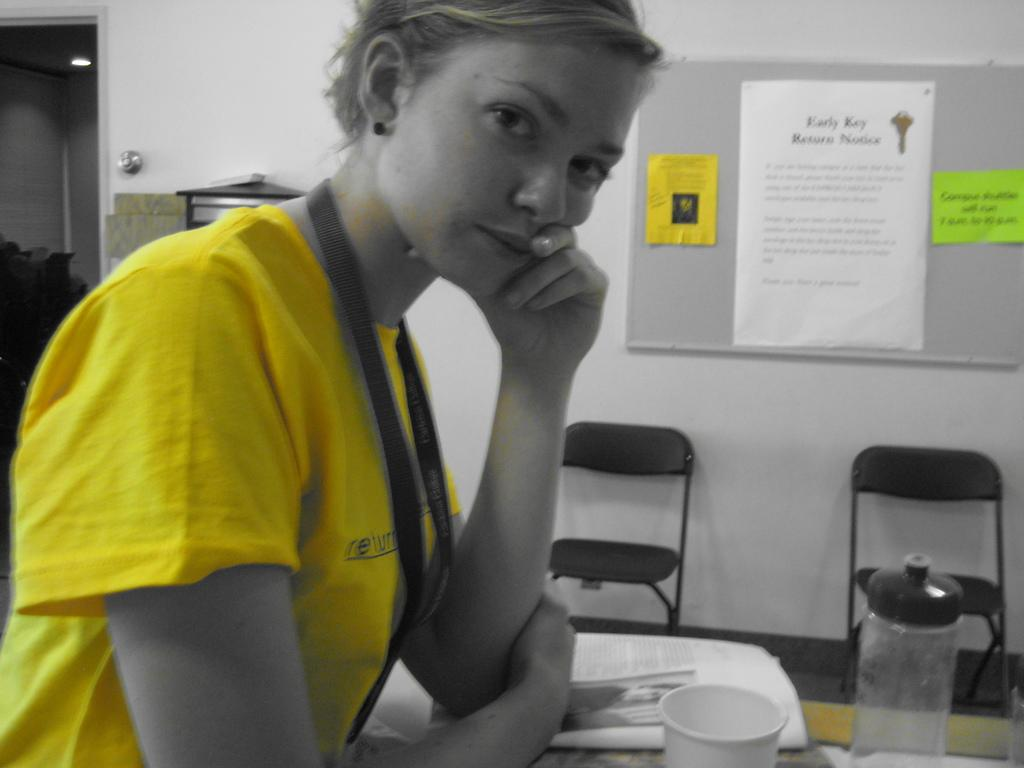<image>
Provide a brief description of the given image. A woman sits in a room that has a notice about returning keys. 